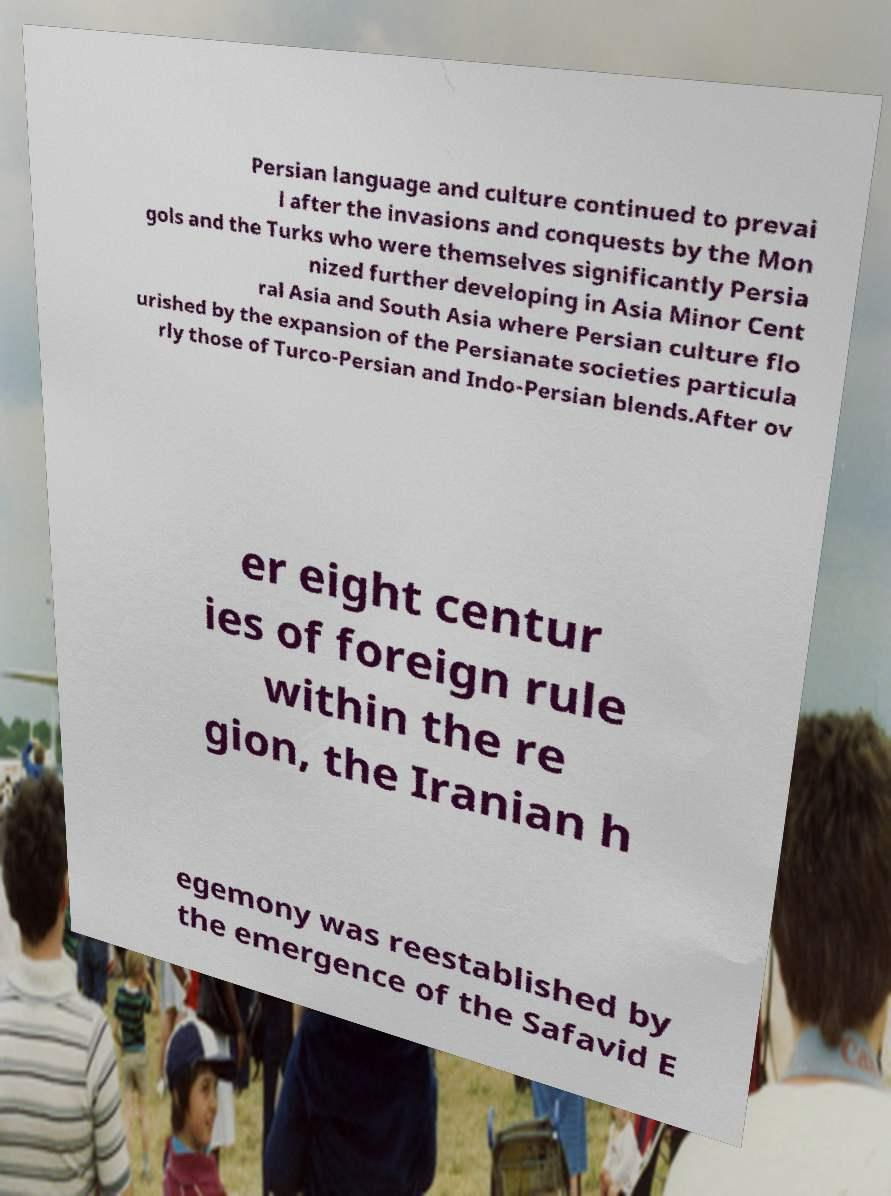What messages or text are displayed in this image? I need them in a readable, typed format. Persian language and culture continued to prevai l after the invasions and conquests by the Mon gols and the Turks who were themselves significantly Persia nized further developing in Asia Minor Cent ral Asia and South Asia where Persian culture flo urished by the expansion of the Persianate societies particula rly those of Turco-Persian and Indo-Persian blends.After ov er eight centur ies of foreign rule within the re gion, the Iranian h egemony was reestablished by the emergence of the Safavid E 